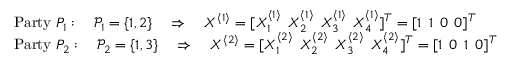<formula> <loc_0><loc_0><loc_500><loc_500>\begin{array} { r l } & { P a r t y P _ { 1 } \colon \quad \mathcal { P } _ { 1 } = \{ 1 , 2 \} \quad \Rightarrow \quad X ^ { \langle 1 \rangle } = [ X _ { 1 } ^ { \langle 1 \rangle } \, X _ { 2 } ^ { \langle 1 \rangle } \, X _ { 3 } ^ { \langle 1 \rangle } \, X _ { 4 } ^ { \langle 1 \rangle } ] ^ { T } = [ 1 \, 1 \, 0 \, 0 ] ^ { T } } \\ & { P a r t y P _ { 2 } \colon \quad \mathcal { P } _ { 2 } = \{ 1 , 3 \} \quad \Rightarrow \quad X ^ { \langle 2 \rangle } = [ X _ { 1 } ^ { \langle 2 \rangle } \, X _ { 2 } ^ { \langle 2 \rangle } \, X _ { 3 } ^ { \langle 2 \rangle } \, X _ { 4 } ^ { \langle 2 \rangle } ] ^ { T } = [ 1 \, 0 \, 1 \, 0 ] ^ { T } } \end{array}</formula> 